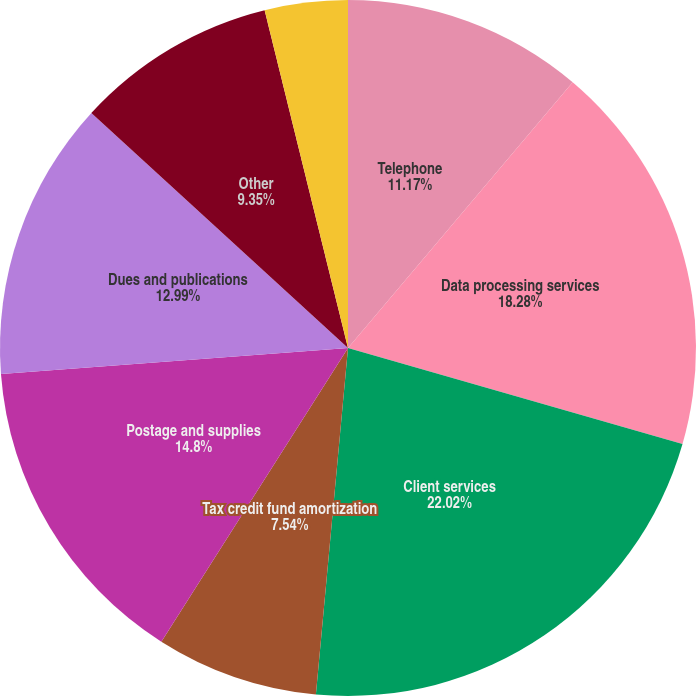Convert chart. <chart><loc_0><loc_0><loc_500><loc_500><pie_chart><fcel>Telephone<fcel>Data processing services<fcel>Client services<fcel>Tax credit fund amortization<fcel>Postage and supplies<fcel>Dues and publications<fcel>Other<fcel>Total other noninterest<nl><fcel>11.17%<fcel>18.28%<fcel>22.02%<fcel>7.54%<fcel>14.8%<fcel>12.99%<fcel>9.35%<fcel>3.85%<nl></chart> 